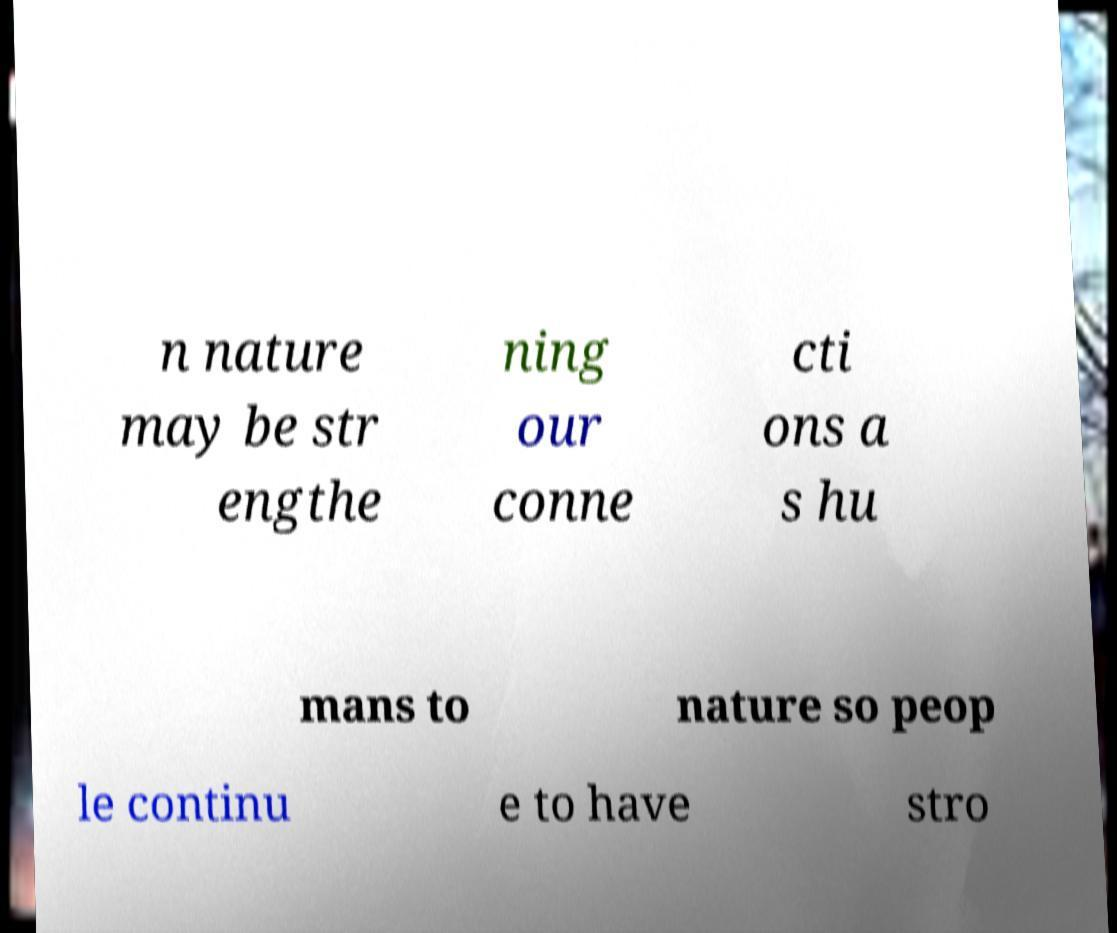I need the written content from this picture converted into text. Can you do that? n nature may be str engthe ning our conne cti ons a s hu mans to nature so peop le continu e to have stro 